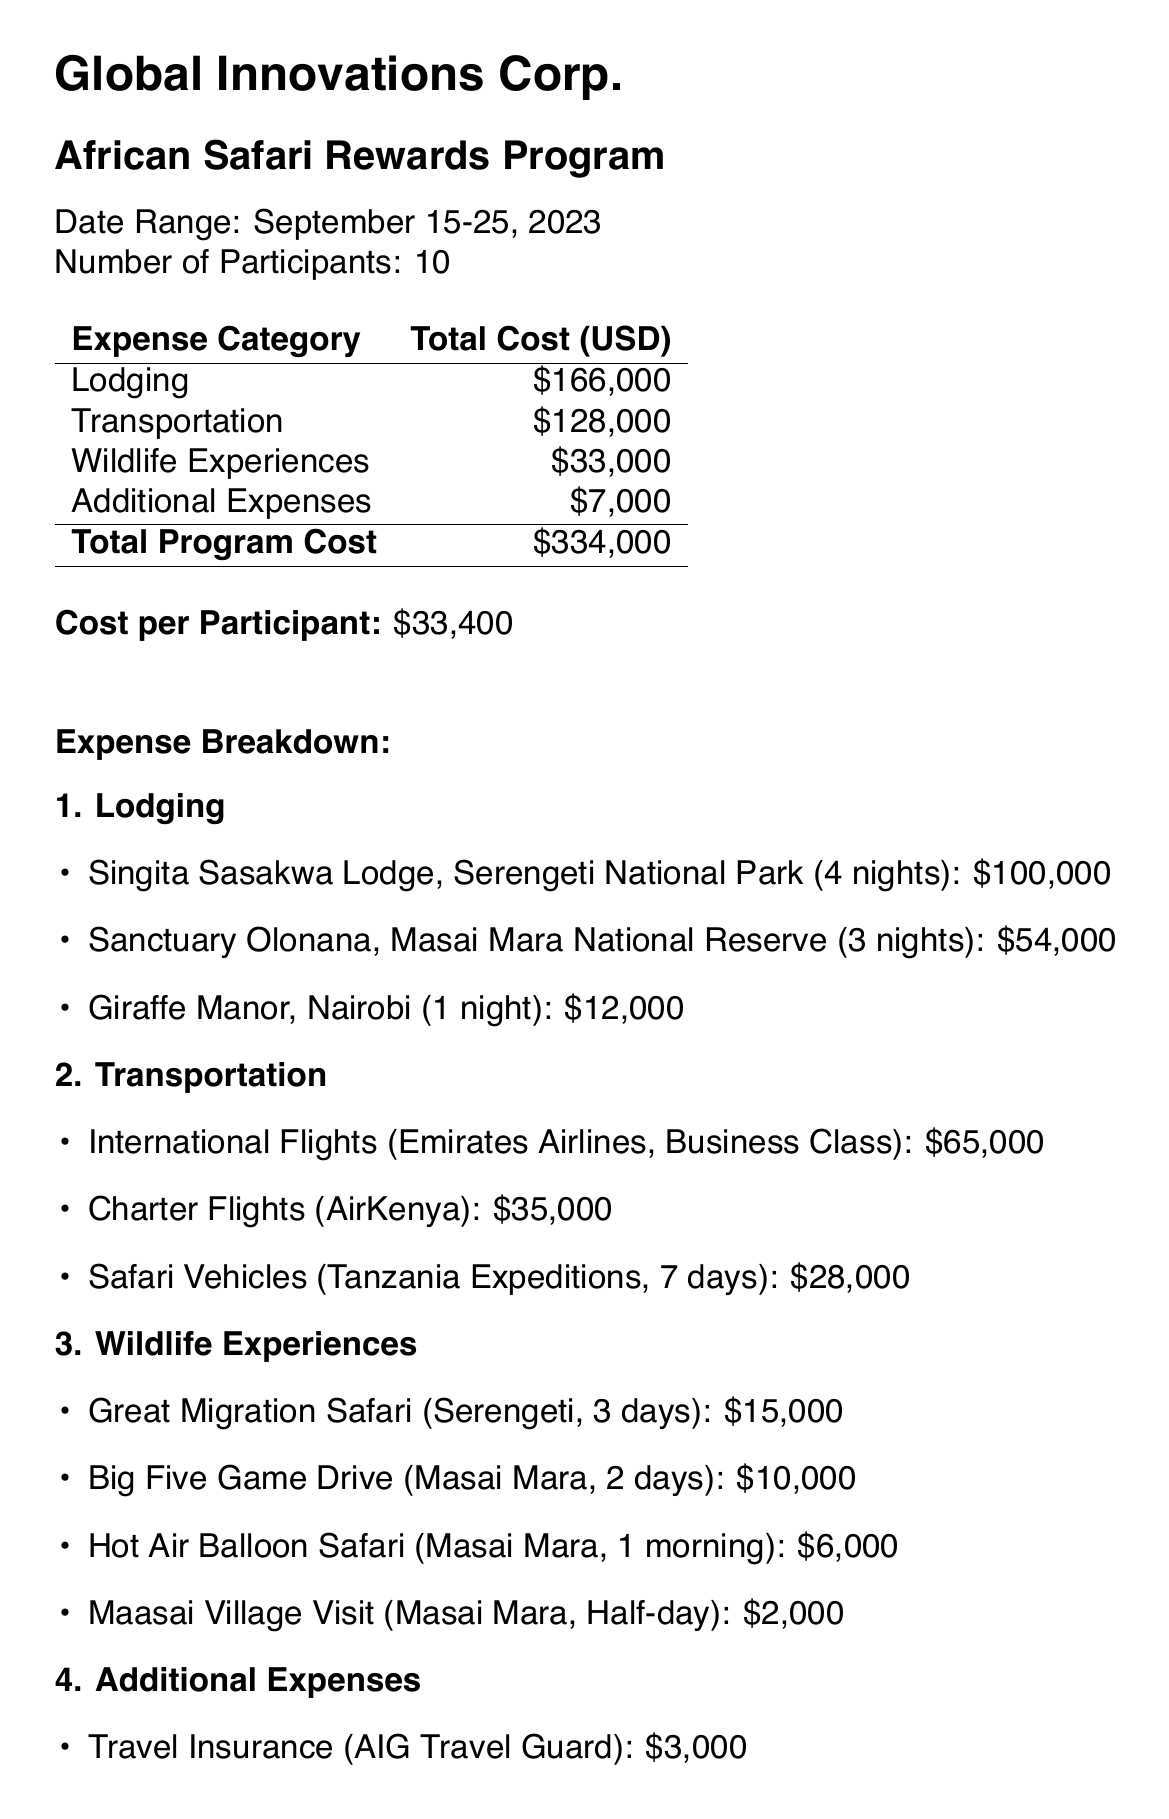what is the program name? The program name is stated prominently in the document, specifically mentioned as "African Safari Rewards Program."
Answer: African Safari Rewards Program how many nights at Singita Sasakwa Lodge? The document lists the number of nights spent at Singita Sasakwa Lodge, which is mentioned as 4.
Answer: 4 what is the total cost of additional expenses? The total cost of additional expenses is explicitly stated in the expense summary section of the document.
Answer: 7000 who is the guide for the Great Migration Safari? The document identifies the guide for the Great Migration Safari as "John Mbogo."
Answer: John Mbogo which provider is used for the international flights? The document specifies the provider for international flights as "Emirates Airlines."
Answer: Emirates Airlines what is the total program cost? The total program cost is summarized at the bottom of the expense category table in the document.
Answer: 334000 how many participants are there in the program? The document clearly states the number of participants in the program as 10.
Answer: 10 what is the cost per participant? The document calculates the cost per participant, described in the summary section as $33,400.
Answer: 33400 what is included in the safari gear package? The document includes a brief description of the contents of the safari gear package, listing specific items.
Answer: Binoculars, safari hat, insect repellent, sunscreen 